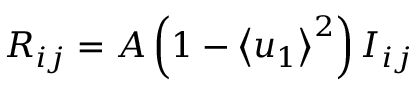<formula> <loc_0><loc_0><loc_500><loc_500>{ R _ { i j } } = A \left ( { 1 - { { \left \langle { { u _ { 1 } } } \right \rangle } ^ { 2 } } } \right ) I _ { i j }</formula> 